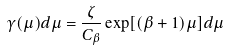Convert formula to latex. <formula><loc_0><loc_0><loc_500><loc_500>\gamma ( \mu ) d \mu = \frac { \zeta } { C _ { \beta } } \exp [ ( \beta + 1 ) \mu ] d \mu</formula> 